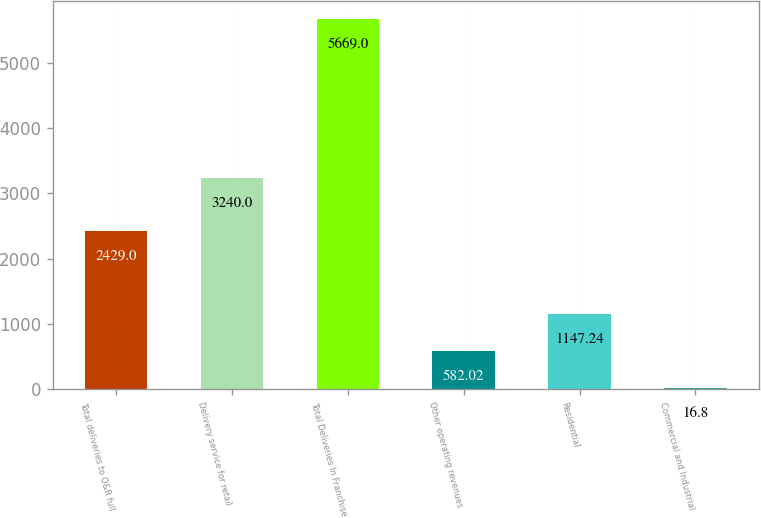Convert chart to OTSL. <chart><loc_0><loc_0><loc_500><loc_500><bar_chart><fcel>Total deliveries to O&R full<fcel>Delivery service for retail<fcel>Total Deliveries In Franchise<fcel>Other operating revenues<fcel>Residential<fcel>Commercial and Industrial<nl><fcel>2429<fcel>3240<fcel>5669<fcel>582.02<fcel>1147.24<fcel>16.8<nl></chart> 